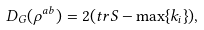<formula> <loc_0><loc_0><loc_500><loc_500>D _ { G } ( \rho ^ { a b } ) = 2 ( t r S - \max \{ k _ { i } \} ) ,</formula> 